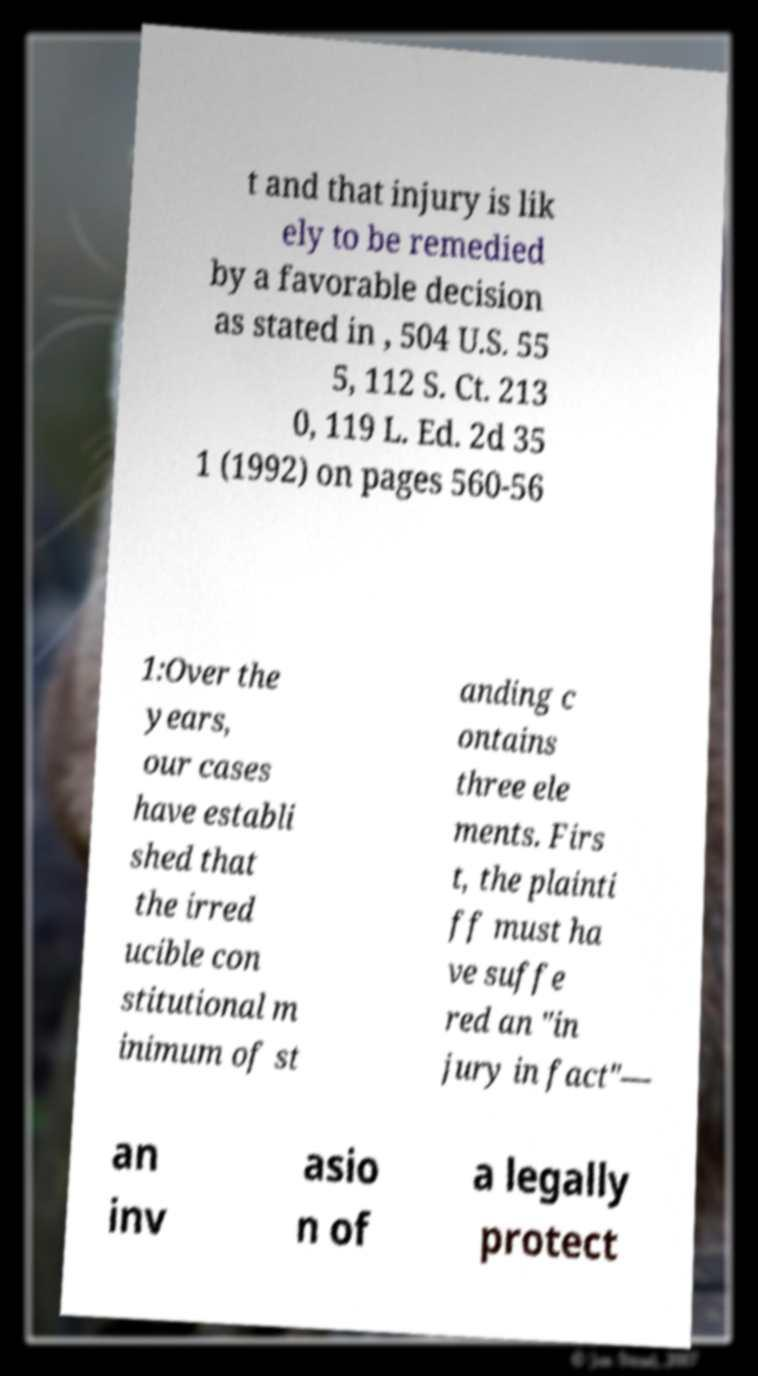Please read and relay the text visible in this image. What does it say? t and that injury is lik ely to be remedied by a favorable decision as stated in , 504 U.S. 55 5, 112 S. Ct. 213 0, 119 L. Ed. 2d 35 1 (1992) on pages 560-56 1:Over the years, our cases have establi shed that the irred ucible con stitutional m inimum of st anding c ontains three ele ments. Firs t, the plainti ff must ha ve suffe red an "in jury in fact"— an inv asio n of a legally protect 